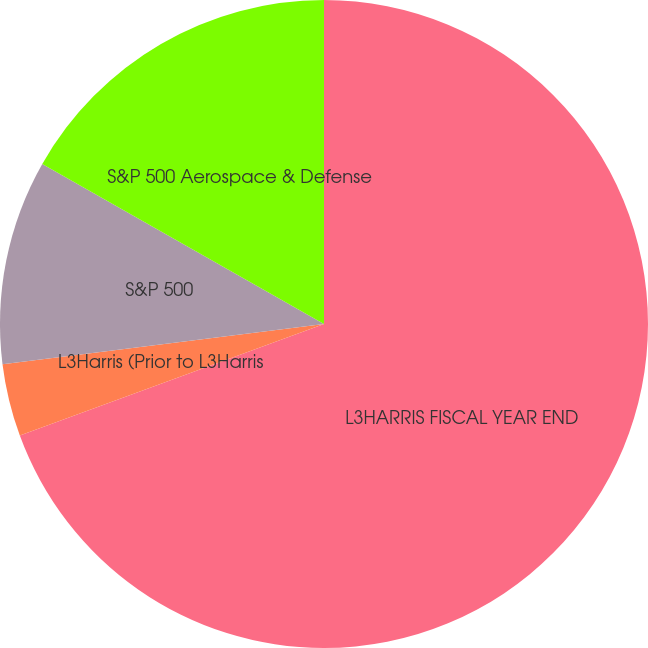Convert chart to OTSL. <chart><loc_0><loc_0><loc_500><loc_500><pie_chart><fcel>L3HARRIS FISCAL YEAR END<fcel>L3Harris (Prior to L3Harris<fcel>S&P 500<fcel>S&P 500 Aerospace & Defense<nl><fcel>69.41%<fcel>3.62%<fcel>10.2%<fcel>16.78%<nl></chart> 